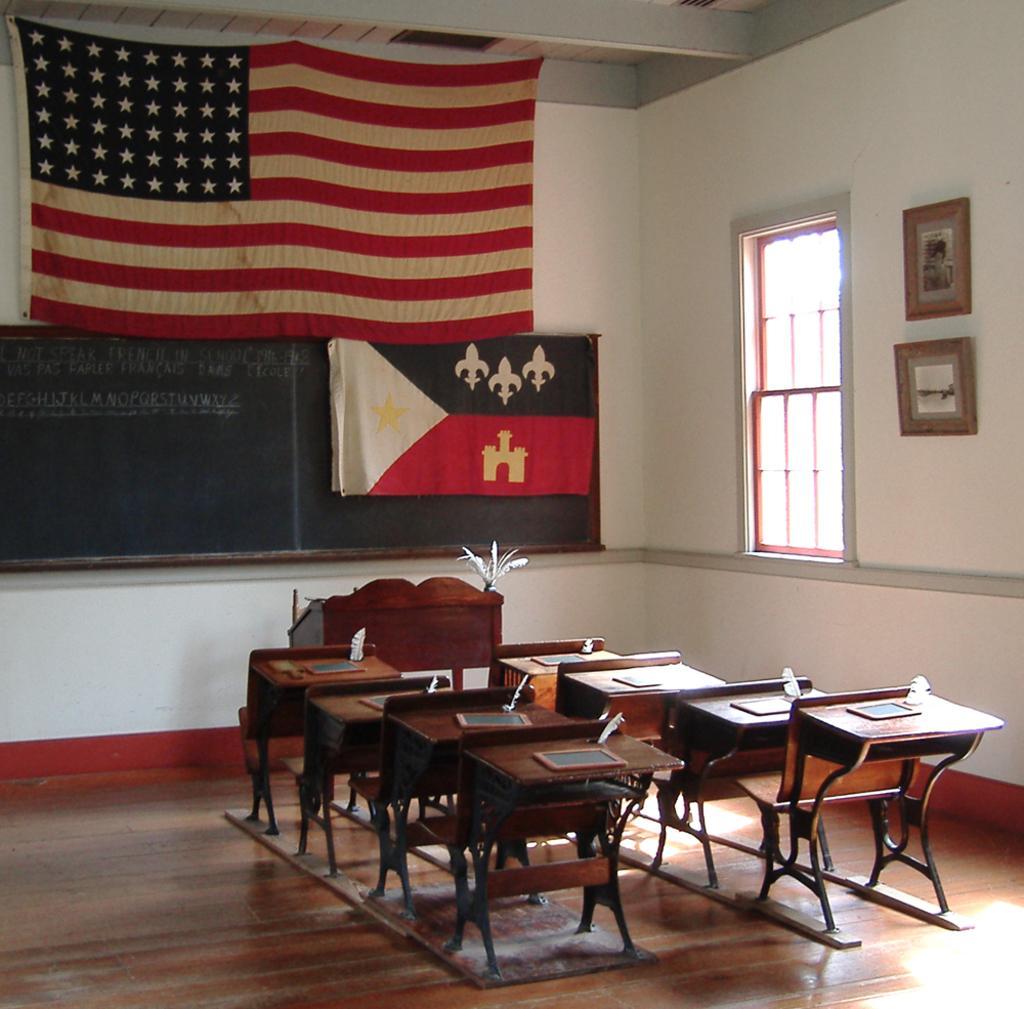Please provide a concise description of this image. This picture is consists of a room where there is a window at the right side of the image and a board and a flag at the center of the image, there is a table and benches at the center of the image. 